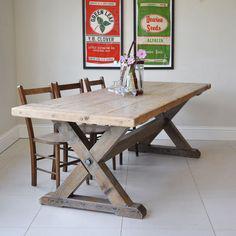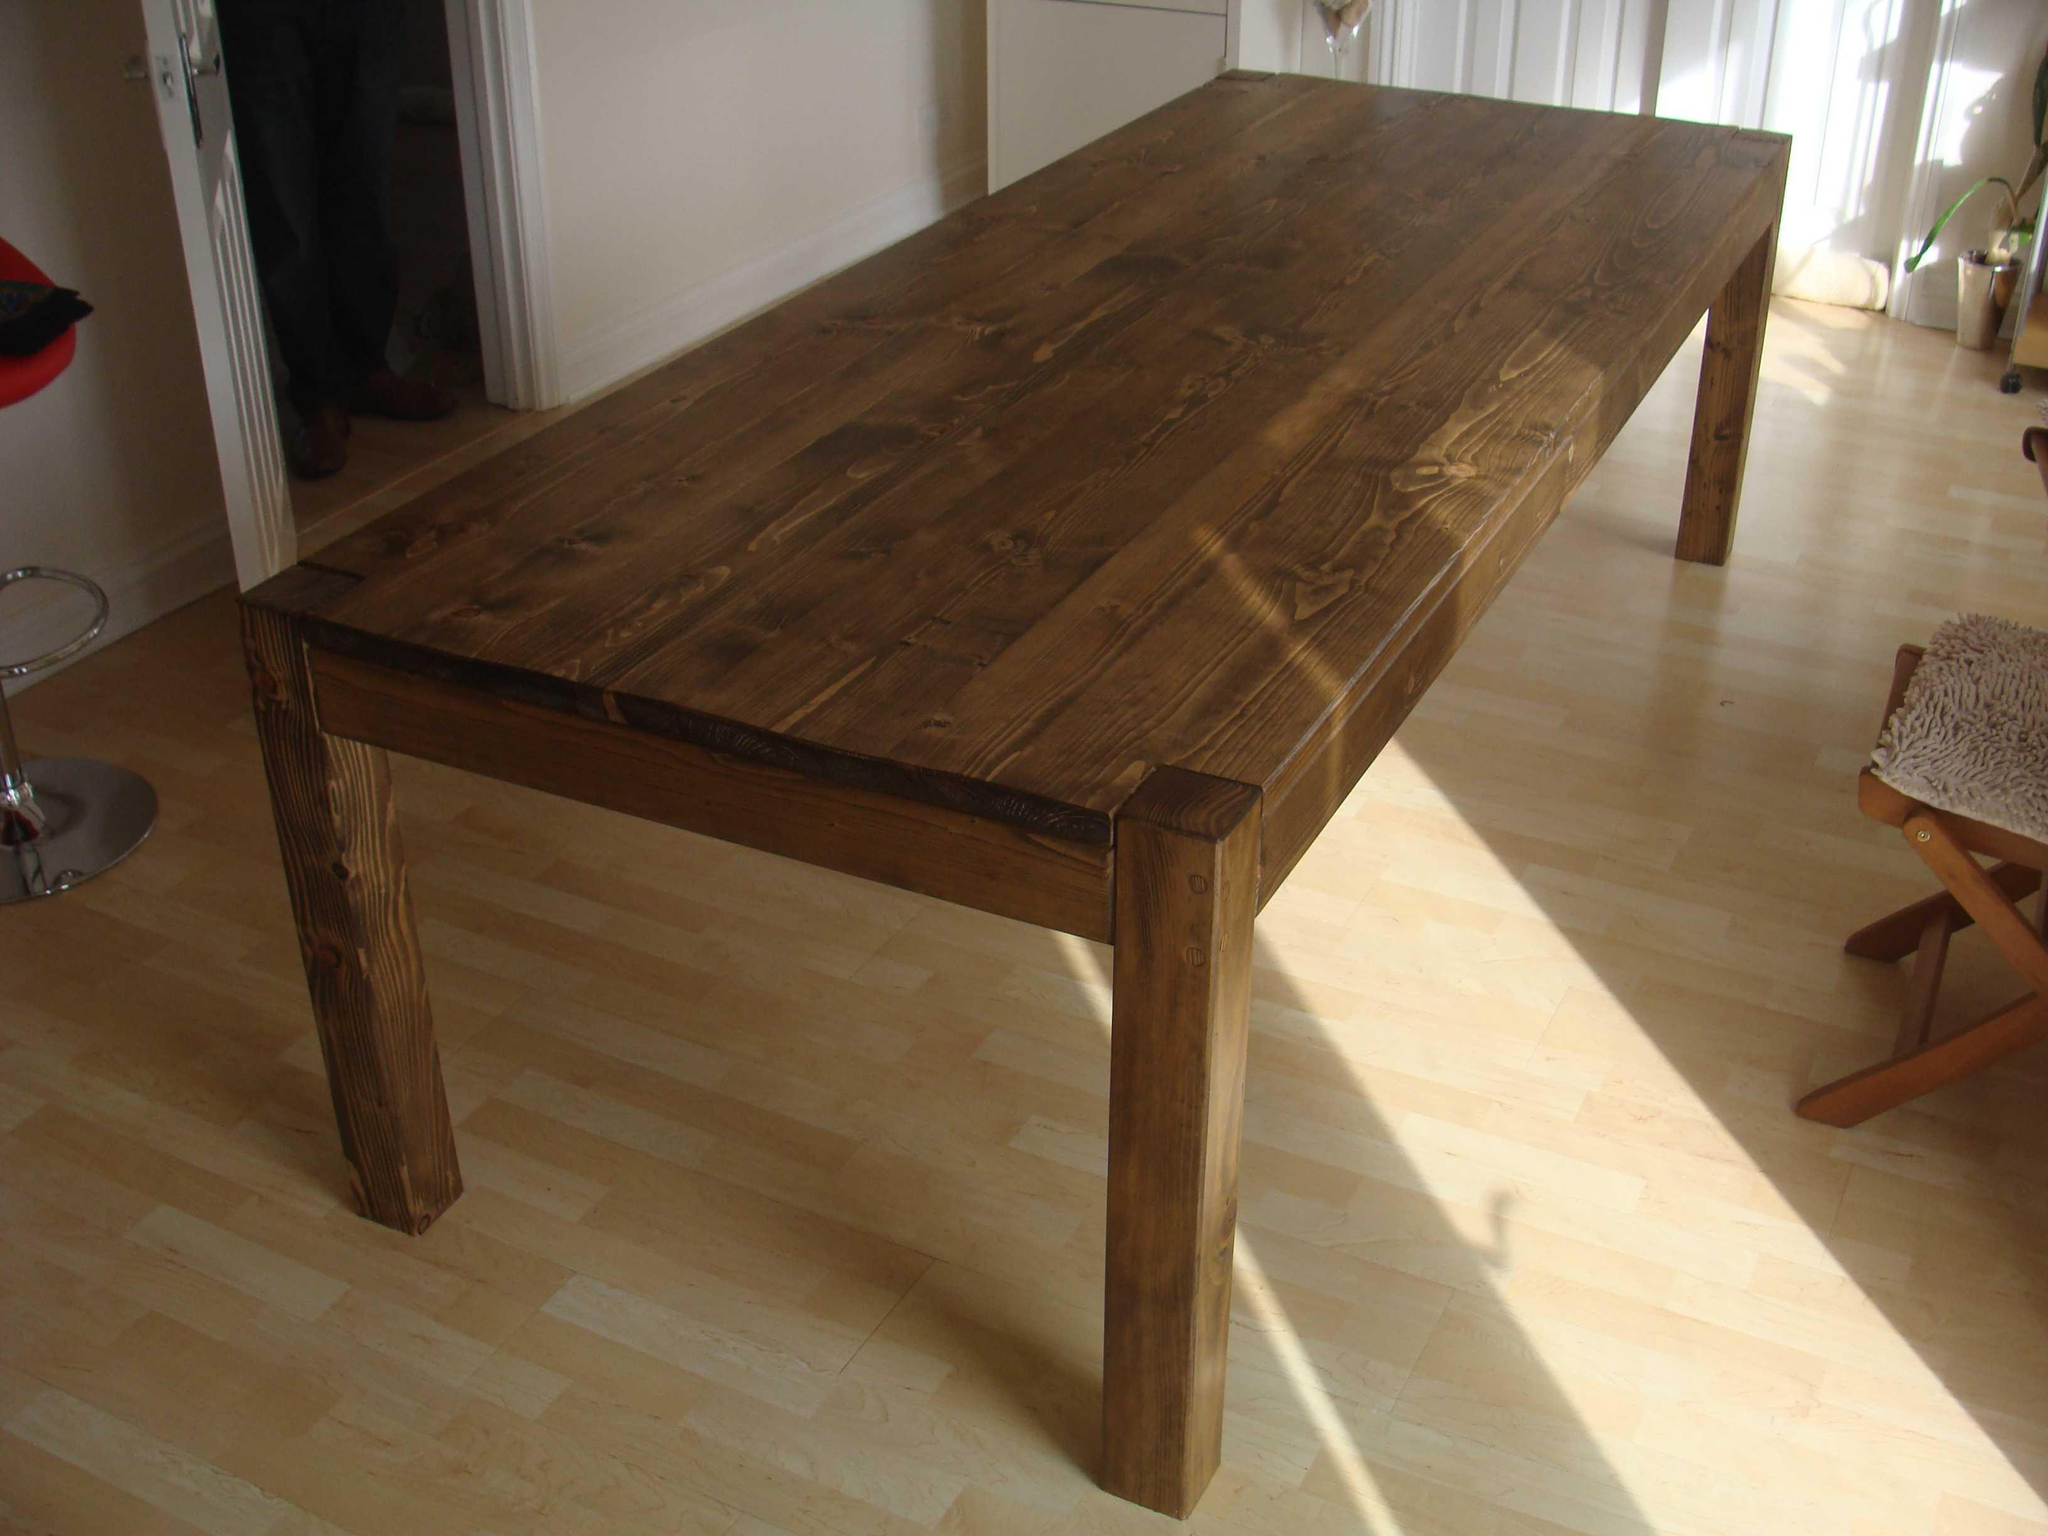The first image is the image on the left, the second image is the image on the right. For the images displayed, is the sentence "There are at least two frames on the wall." factually correct? Answer yes or no. Yes. 